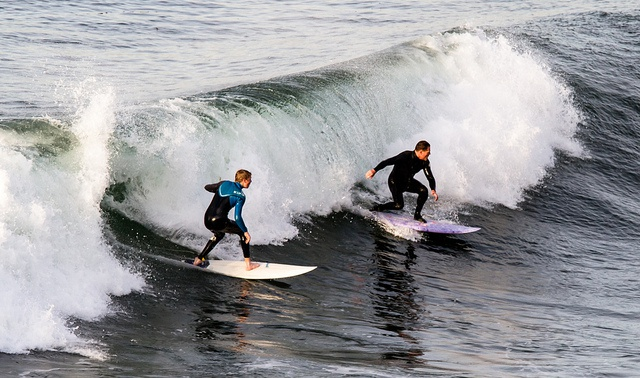Describe the objects in this image and their specific colors. I can see people in darkgray, black, lightgray, and gray tones, people in darkgray, black, gray, and lightgray tones, surfboard in darkgray, ivory, tan, black, and gray tones, and surfboard in darkgray, violet, lavender, and pink tones in this image. 